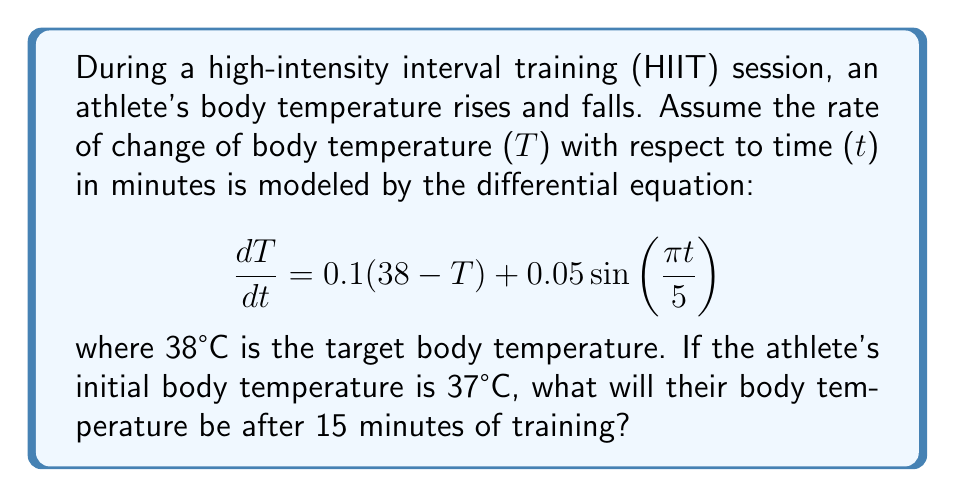What is the answer to this math problem? To solve this problem, we need to use the method for solving first-order linear differential equations.

1) First, let's identify the parts of our differential equation:
   $$\frac{dT}{dt} + 0.1T = 3.8 + 0.05\sin(\frac{\pi t}{5})$$

2) This is in the form of $$\frac{dy}{dx} + P(x)y = Q(x)$$
   where $P(x) = 0.1$ and $Q(x) = 3.8 + 0.05\sin(\frac{\pi t}{5})$

3) The integrating factor is $e^{\int P(x)dx} = e^{0.1t}$

4) Multiply both sides of the equation by the integrating factor:
   $$e^{0.1t}\frac{dT}{dt} + 0.1Te^{0.1t} = 3.8e^{0.1t} + 0.05e^{0.1t}\sin(\frac{\pi t}{5})$$

5) The left side is now the derivative of $Te^{0.1t}$, so we can integrate both sides:
   $$Te^{0.1t} = 38e^{0.1t} - 0.25e^{0.1t}\cos(\frac{\pi t}{5}) + 0.1e^{0.1t}\sin(\frac{\pi t}{5}) + C$$

6) Solve for T:
   $$T = 38 - 0.25\cos(\frac{\pi t}{5}) + 0.1\sin(\frac{\pi t}{5}) + Ce^{-0.1t}$$

7) Use the initial condition T(0) = 37 to find C:
   $$37 = 38 - 0.25 + C$$
   $$C = -0.75$$

8) Our final solution is:
   $$T = 38 - 0.25\cos(\frac{\pi t}{5}) + 0.1\sin(\frac{\pi t}{5}) - 0.75e^{-0.1t}$$

9) To find T(15), we plug in t = 15:
   $$T(15) = 38 - 0.25\cos(3\pi) + 0.1\sin(3\pi) - 0.75e^{-1.5}$$
Answer: $T(15) \approx 37.83°C$ 